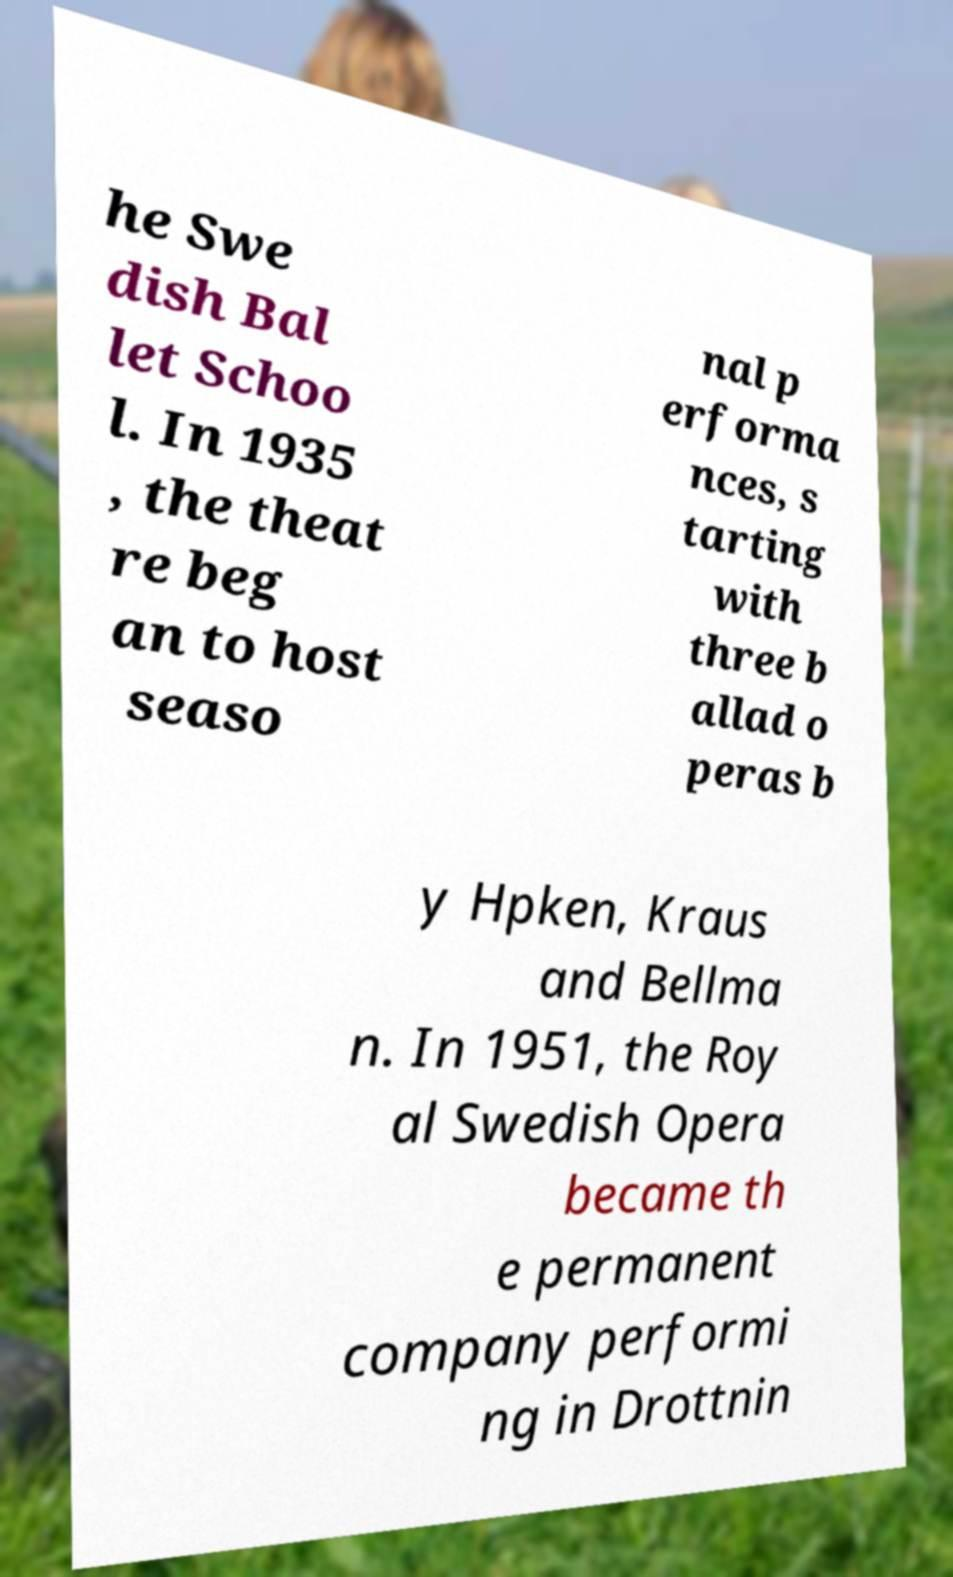Please identify and transcribe the text found in this image. he Swe dish Bal let Schoo l. In 1935 , the theat re beg an to host seaso nal p erforma nces, s tarting with three b allad o peras b y Hpken, Kraus and Bellma n. In 1951, the Roy al Swedish Opera became th e permanent company performi ng in Drottnin 